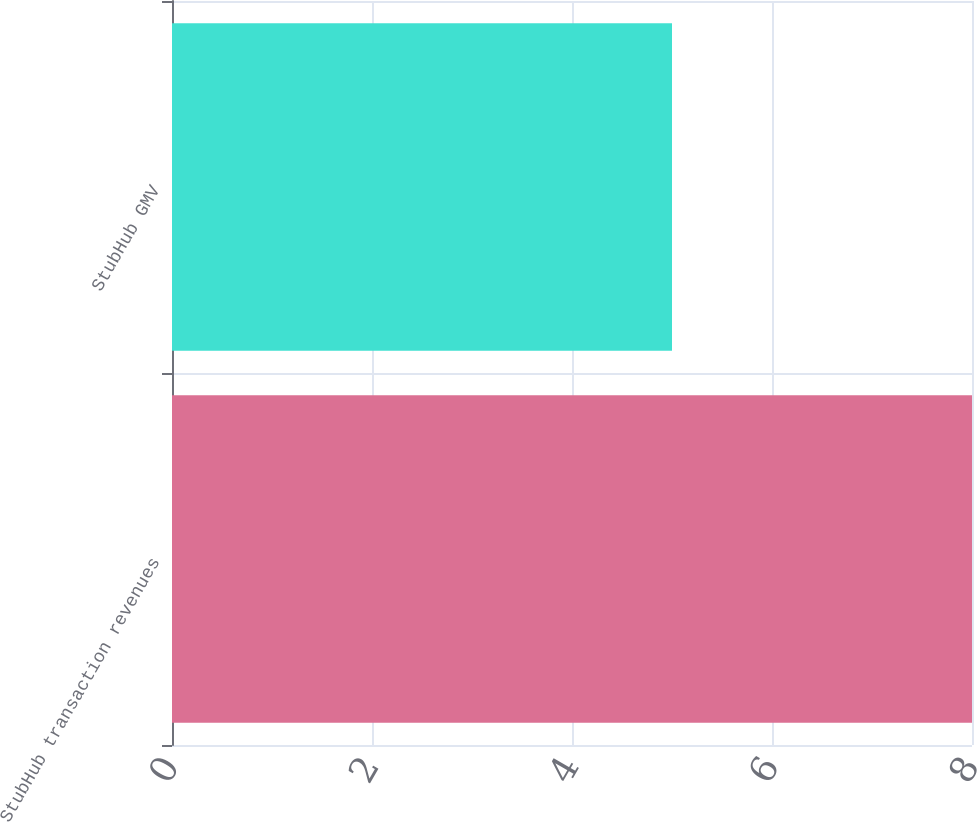Convert chart to OTSL. <chart><loc_0><loc_0><loc_500><loc_500><bar_chart><fcel>StubHub transaction revenues<fcel>StubHub GMV<nl><fcel>8<fcel>5<nl></chart> 